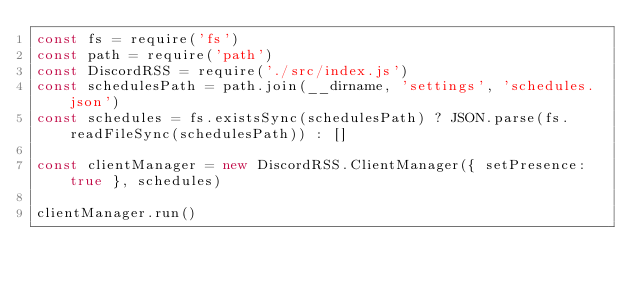<code> <loc_0><loc_0><loc_500><loc_500><_JavaScript_>const fs = require('fs')
const path = require('path')
const DiscordRSS = require('./src/index.js')
const schedulesPath = path.join(__dirname, 'settings', 'schedules.json')
const schedules = fs.existsSync(schedulesPath) ? JSON.parse(fs.readFileSync(schedulesPath)) : []

const clientManager = new DiscordRSS.ClientManager({ setPresence: true }, schedules)

clientManager.run()
</code> 